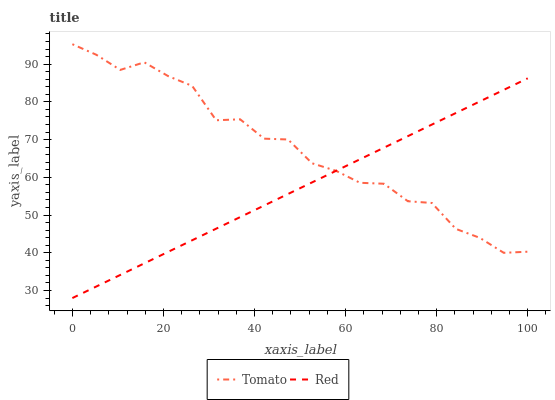Does Red have the minimum area under the curve?
Answer yes or no. Yes. Does Tomato have the maximum area under the curve?
Answer yes or no. Yes. Does Red have the maximum area under the curve?
Answer yes or no. No. Is Red the smoothest?
Answer yes or no. Yes. Is Tomato the roughest?
Answer yes or no. Yes. Is Red the roughest?
Answer yes or no. No. Does Red have the lowest value?
Answer yes or no. Yes. Does Tomato have the highest value?
Answer yes or no. Yes. Does Red have the highest value?
Answer yes or no. No. Does Red intersect Tomato?
Answer yes or no. Yes. Is Red less than Tomato?
Answer yes or no. No. Is Red greater than Tomato?
Answer yes or no. No. 